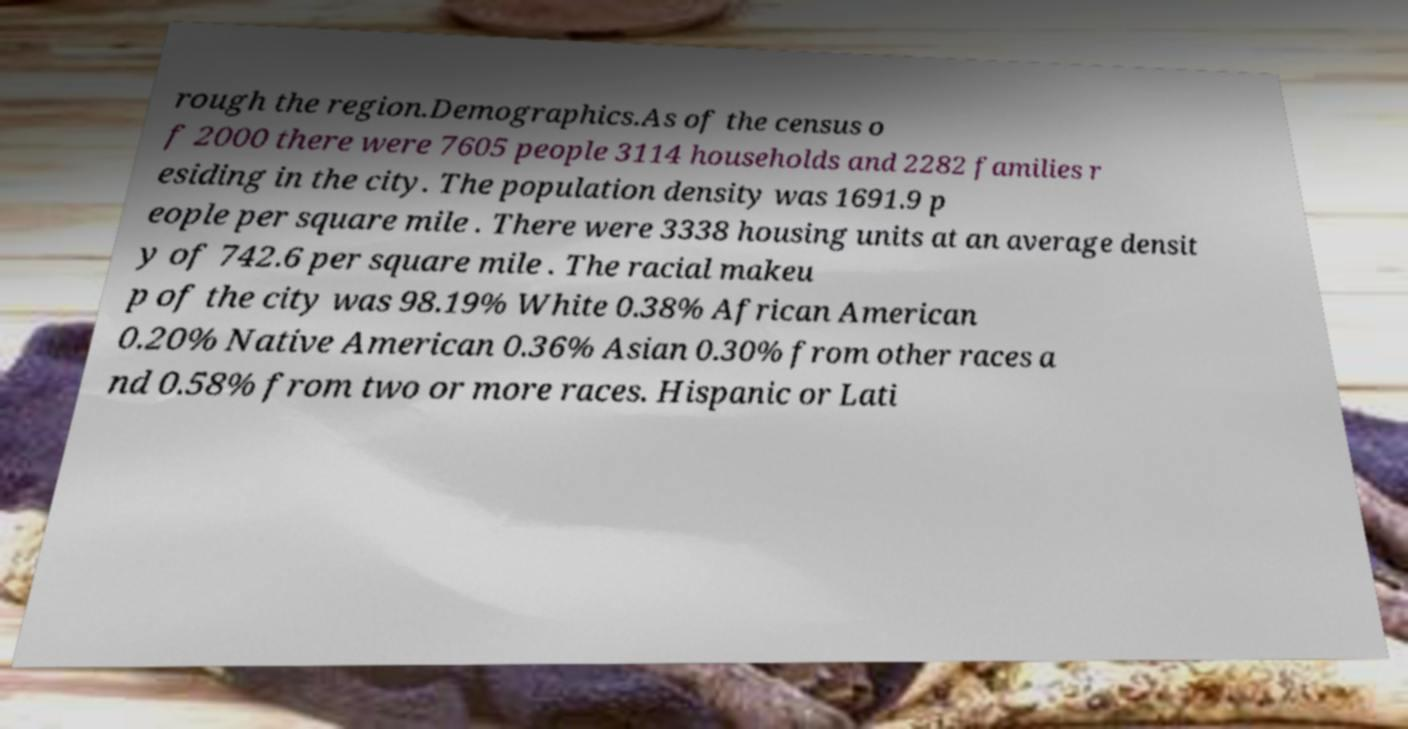Please read and relay the text visible in this image. What does it say? rough the region.Demographics.As of the census o f 2000 there were 7605 people 3114 households and 2282 families r esiding in the city. The population density was 1691.9 p eople per square mile . There were 3338 housing units at an average densit y of 742.6 per square mile . The racial makeu p of the city was 98.19% White 0.38% African American 0.20% Native American 0.36% Asian 0.30% from other races a nd 0.58% from two or more races. Hispanic or Lati 